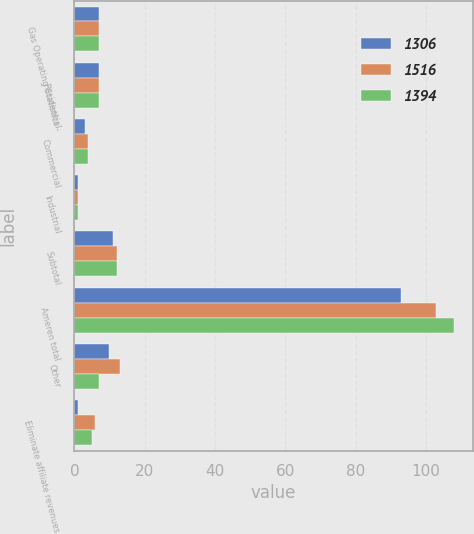<chart> <loc_0><loc_0><loc_500><loc_500><stacked_bar_chart><ecel><fcel>Gas Operating Statistics -<fcel>Residential<fcel>Commercial<fcel>Industrial<fcel>Subtotal<fcel>Ameren total<fcel>Other<fcel>Eliminate affiliate revenues<nl><fcel>1306<fcel>7<fcel>7<fcel>3<fcel>1<fcel>11<fcel>93<fcel>10<fcel>1<nl><fcel>1516<fcel>7<fcel>7<fcel>4<fcel>1<fcel>12<fcel>103<fcel>13<fcel>6<nl><fcel>1394<fcel>7<fcel>7<fcel>4<fcel>1<fcel>12<fcel>108<fcel>7<fcel>5<nl></chart> 